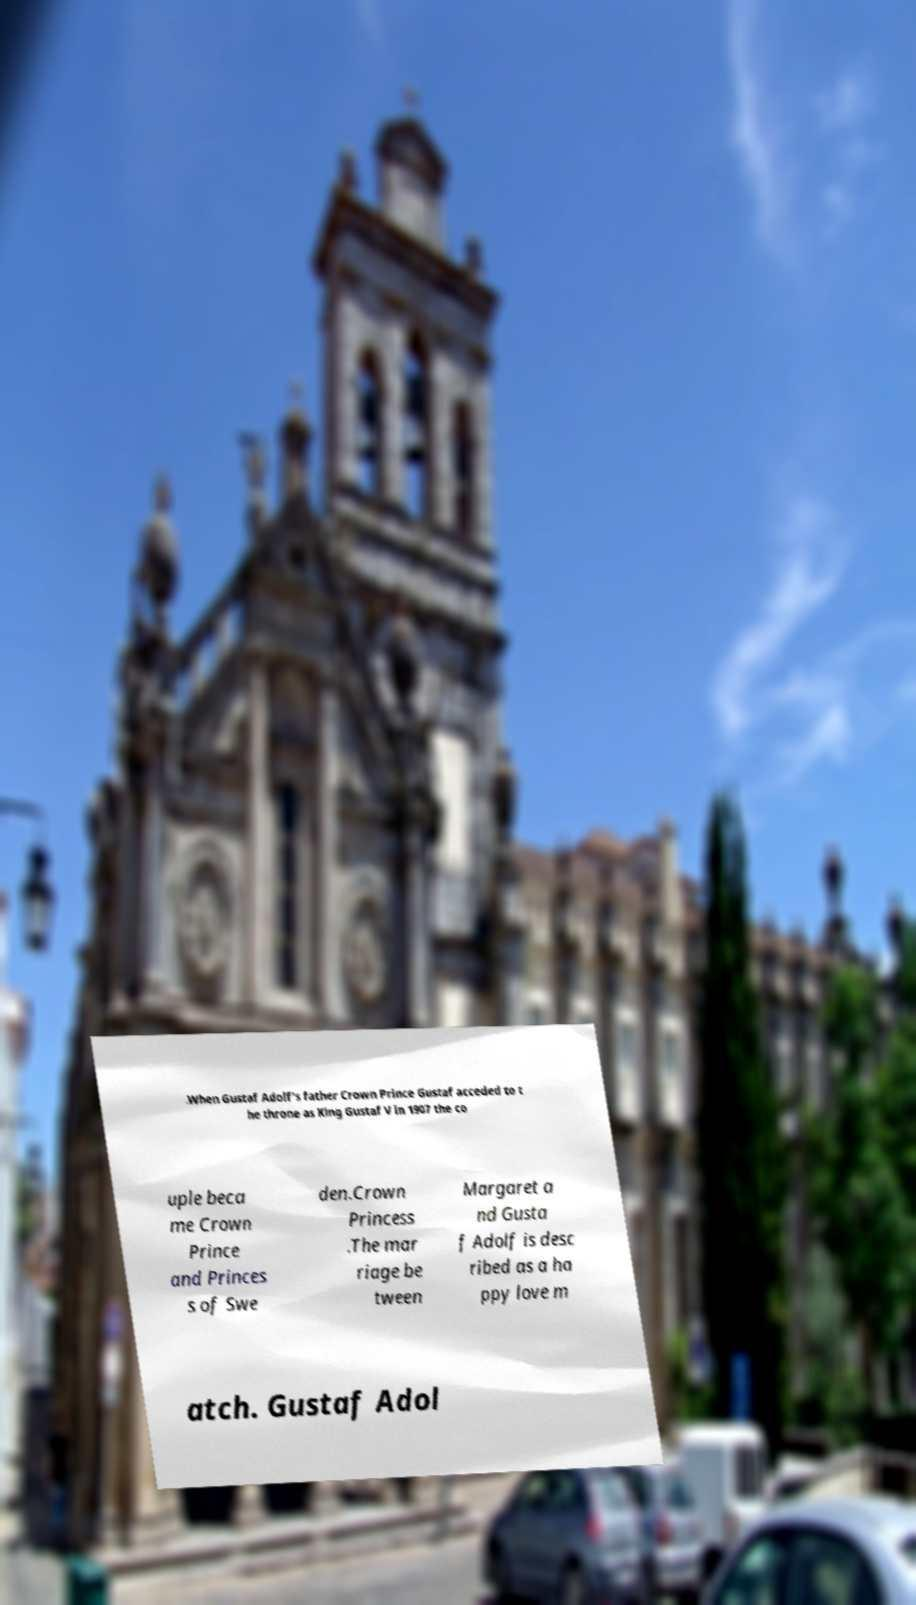Can you read and provide the text displayed in the image?This photo seems to have some interesting text. Can you extract and type it out for me? .When Gustaf Adolf's father Crown Prince Gustaf acceded to t he throne as King Gustaf V in 1907 the co uple beca me Crown Prince and Princes s of Swe den.Crown Princess .The mar riage be tween Margaret a nd Gusta f Adolf is desc ribed as a ha ppy love m atch. Gustaf Adol 